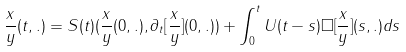<formula> <loc_0><loc_0><loc_500><loc_500>\frac { x } { y } ( t , . ) = S ( t ) ( \frac { x } { y } ( 0 , . ) , \partial _ { t } [ \frac { x } { y } ] ( 0 , . ) ) + \int _ { 0 } ^ { t } U ( t - s ) \Box [ \frac { x } { y } ] ( s , . ) d s</formula> 